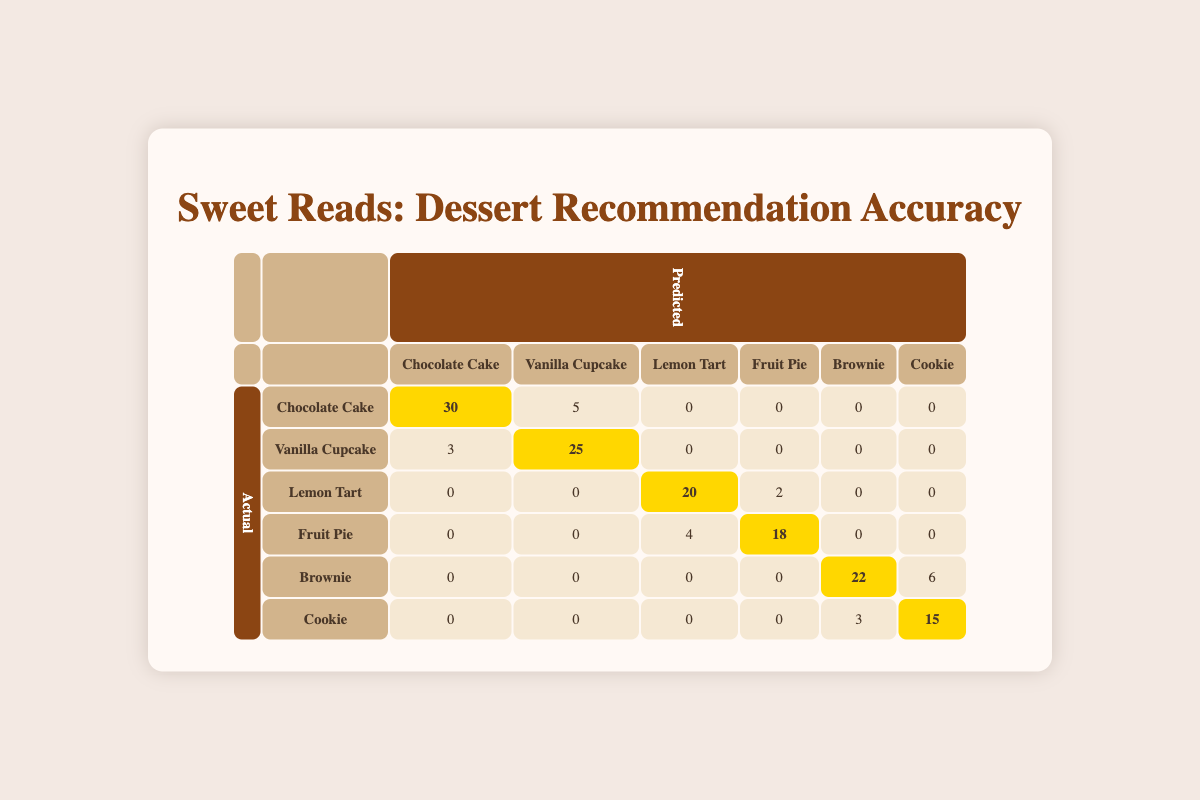What is the total number of accurate recommendations for Chocolate Cake? The table shows that there are 30 accurate recommendations for Chocolate Cake in the "Chocolate Cake" row under "Predicted." This value is directly taken from the confusion matrix.
Answer: 30 How many Vanilla Cupcakes were incorrectly predicted as Chocolate Cake? The table indicates that 5 Vanilla Cupcakes were incorrectly predicted as Chocolate Cake, as shown in the "Vanilla Cupcake" row under "Predicted."
Answer: 5 What percentage of Lemon Tart recommendations were correctly predicted? The number of correct predictions for Lemon Tart is 20, and the total number of actual Lemon Tarts is 22 (20 correct + 2 incorrect). The percentage is (20/22) * 100 = 90.91%.
Answer: 90.91% Is it true that more cookies were accurately predicted than brownies? There are 15 accurate predictions for Cookie and 22 for Brownie. Since 15 is less than 22, it is false that more cookies were accurately predicted than brownies.
Answer: No What is the sum of all incorrect predictions for Fruit Pie? The table shows that 4 Fruit Pies were predicted as Lemon Tart and 0 as other desserts (since the counts for other predictions in the same row are 0). Therefore, the sum of incorrect predictions for Fruit Pie is 4.
Answer: 4 How many instances of cookie recommendations were made, both accurate and inaccurate? The Cookie row indicates that there were 15 accurate predictions (predicted as Cookie) and 3 incorrectly predicted as Brownie. Therefore, total cookie recommendations = 15 + 3 = 18.
Answer: 18 What is the average number of accurate predictions across all dessert types? The accurate predictions for each dessert type are Chocolate Cake (30), Vanilla Cupcake (25), Lemon Tart (20), Fruit Pie (18), Brownie (22), and Cookie (15). Summing these gives 130. There are 6 dessert types, hence the average = 130/6 ≈ 21.67.
Answer: 21.67 How many dessert types have more than 20 correct predictions? In the table, the dessert types with more than 20 correct predictions are Chocolate Cake (30), Vanilla Cupcake (25), Lemon Tart (20), and Brownie (22). Therefore, there are 4 dessert types in total.
Answer: 4 